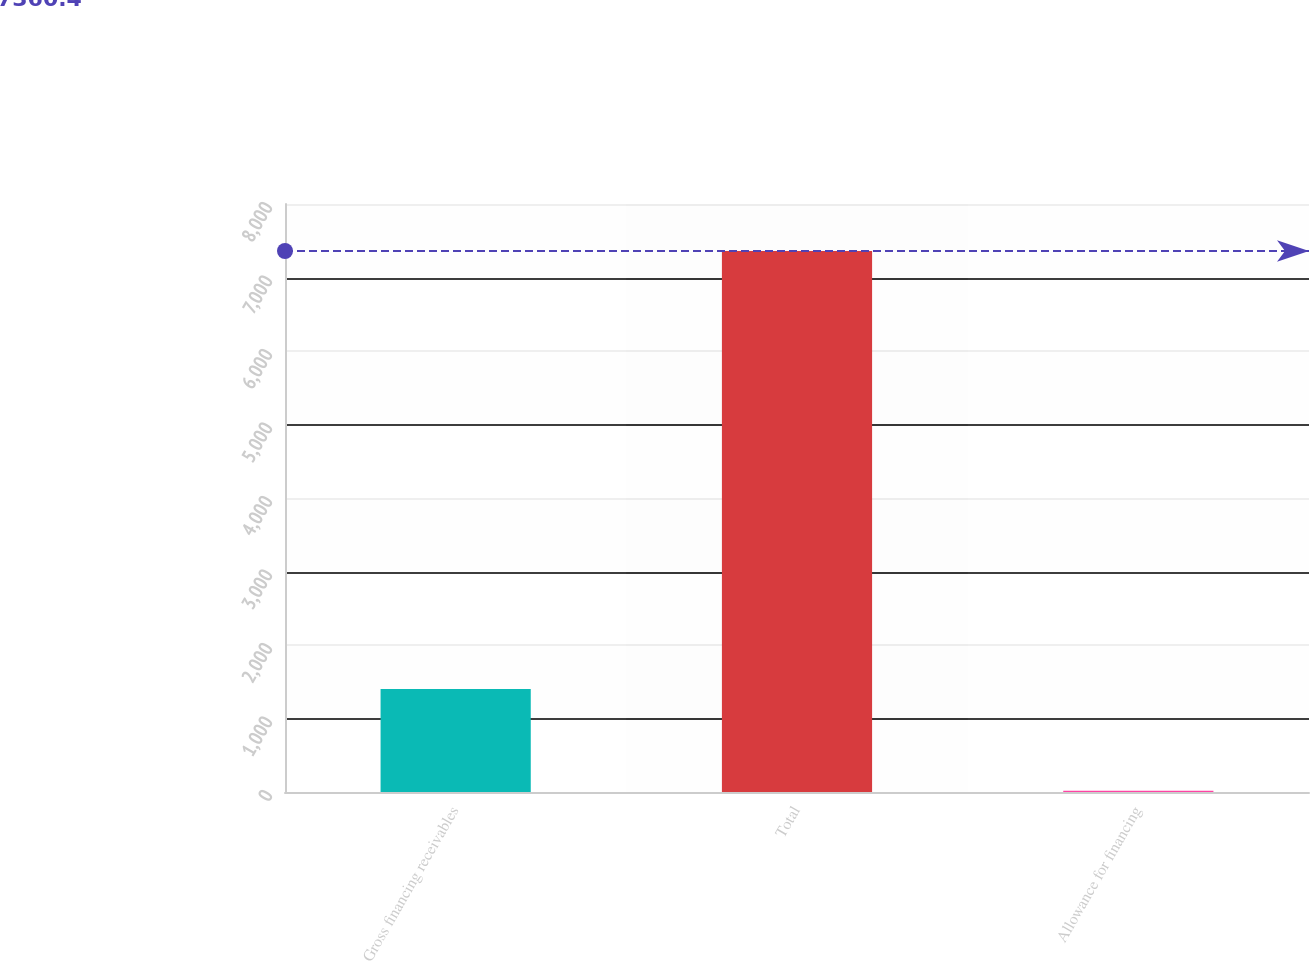Convert chart. <chart><loc_0><loc_0><loc_500><loc_500><bar_chart><fcel>Gross financing receivables<fcel>Total<fcel>Allowance for financing<nl><fcel>1402.8<fcel>7360.4<fcel>16<nl></chart> 